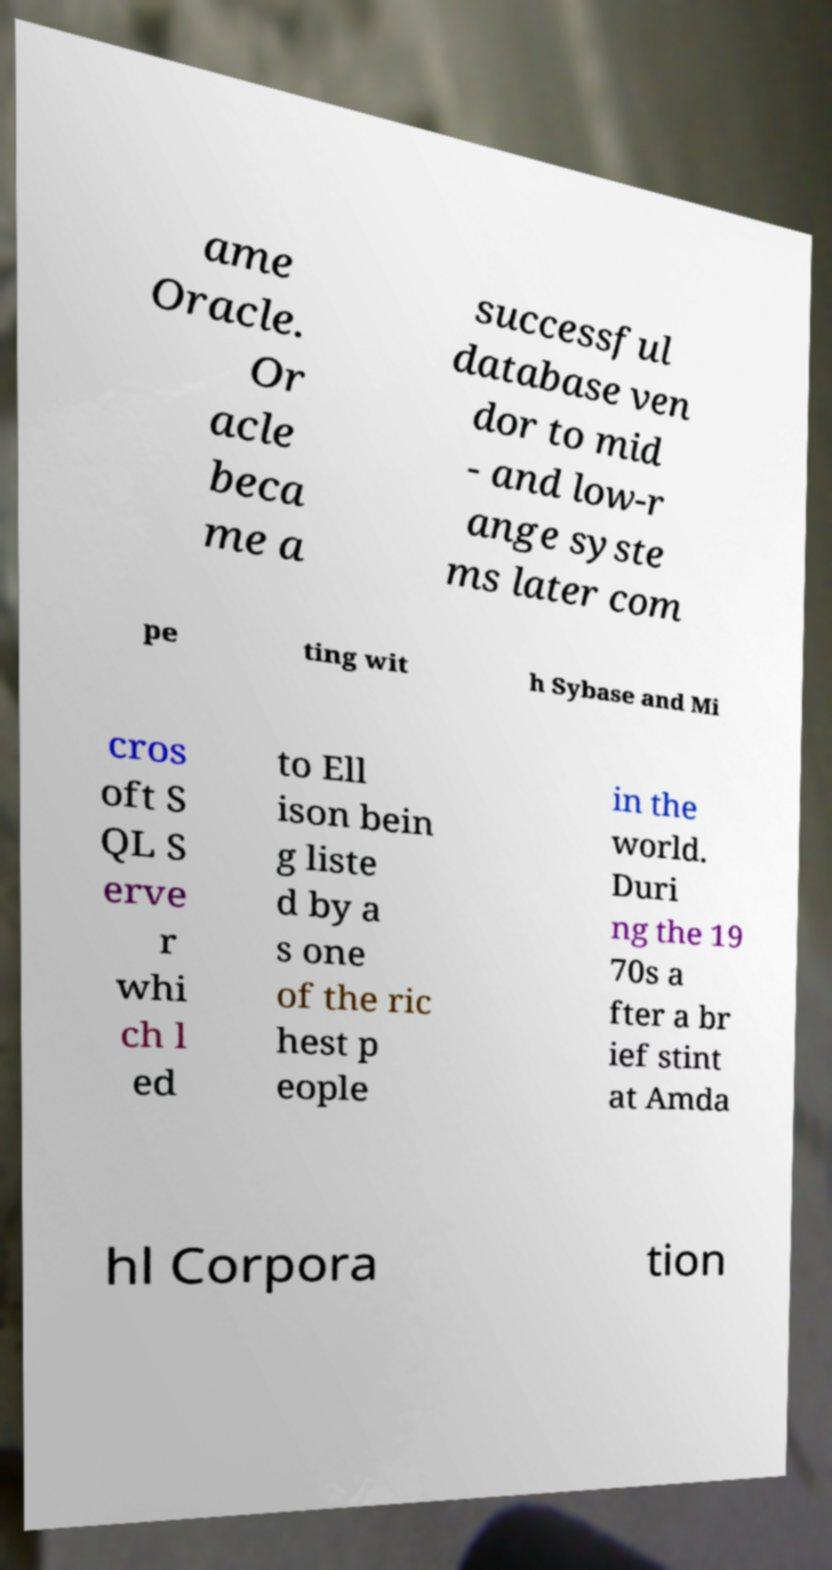What messages or text are displayed in this image? I need them in a readable, typed format. ame Oracle. Or acle beca me a successful database ven dor to mid - and low-r ange syste ms later com pe ting wit h Sybase and Mi cros oft S QL S erve r whi ch l ed to Ell ison bein g liste d by a s one of the ric hest p eople in the world. Duri ng the 19 70s a fter a br ief stint at Amda hl Corpora tion 